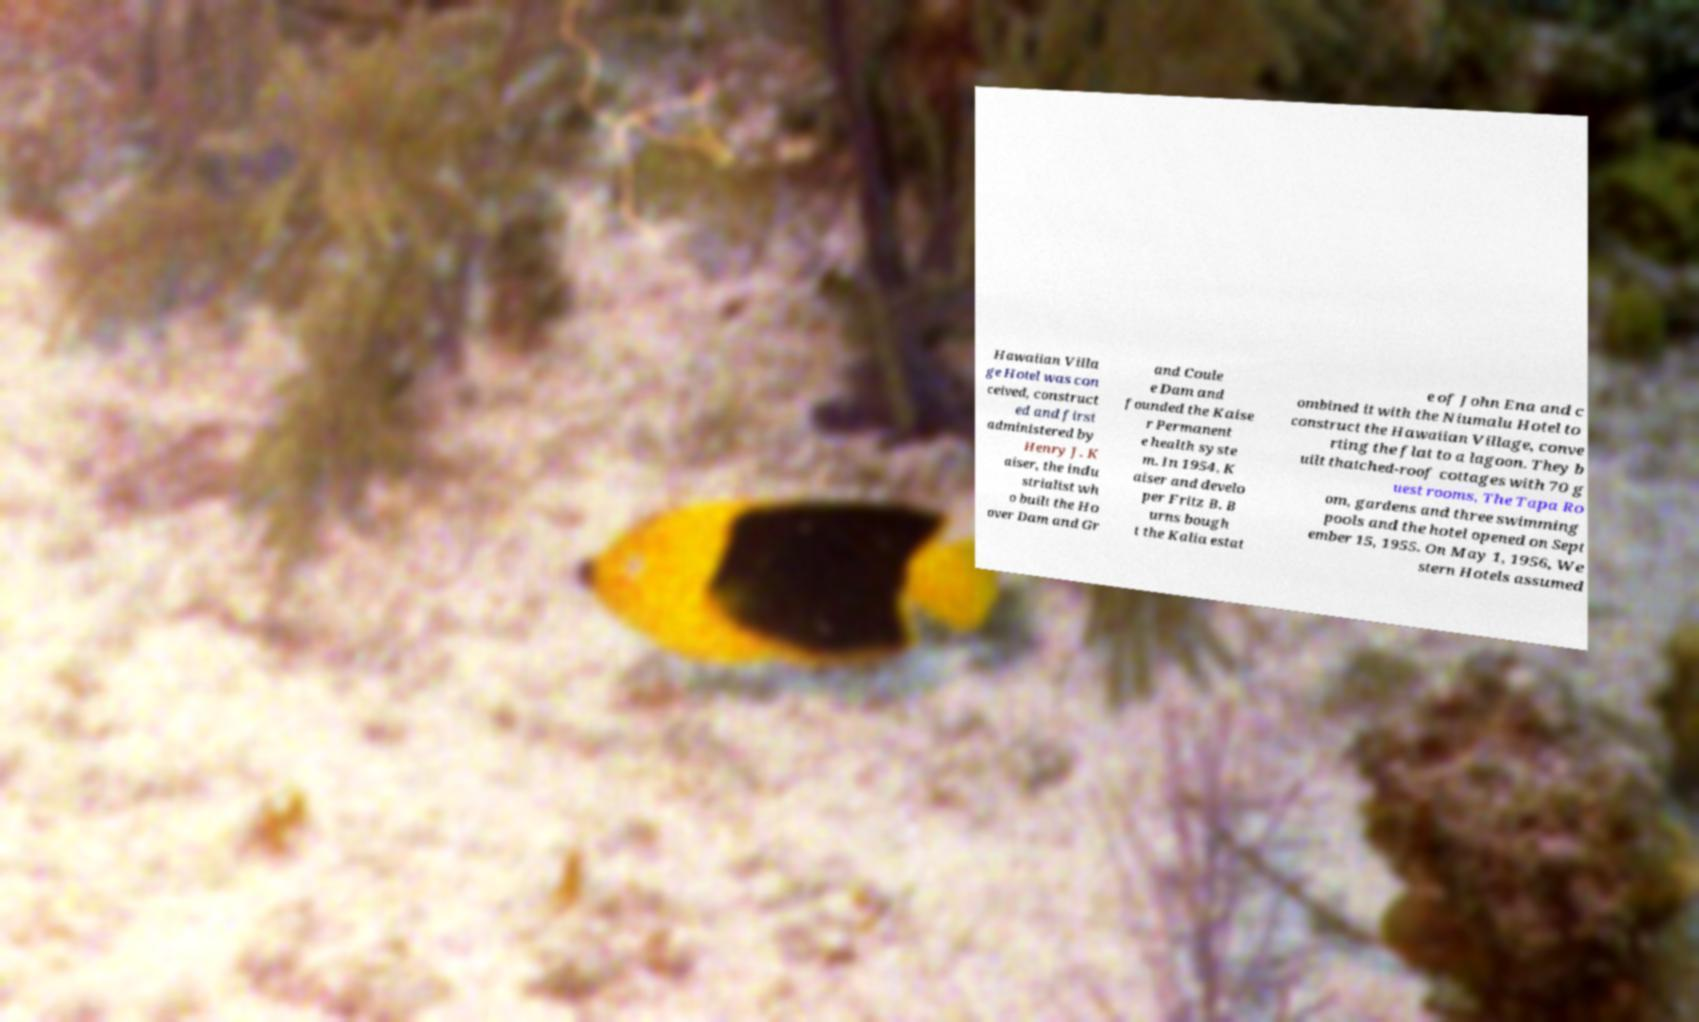Please read and relay the text visible in this image. What does it say? Hawaiian Villa ge Hotel was con ceived, construct ed and first administered by Henry J. K aiser, the indu strialist wh o built the Ho over Dam and Gr and Coule e Dam and founded the Kaise r Permanent e health syste m. In 1954, K aiser and develo per Fritz B. B urns bough t the Kalia estat e of John Ena and c ombined it with the Niumalu Hotel to construct the Hawaiian Village, conve rting the flat to a lagoon. They b uilt thatched-roof cottages with 70 g uest rooms, The Tapa Ro om, gardens and three swimming pools and the hotel opened on Sept ember 15, 1955. On May 1, 1956, We stern Hotels assumed 